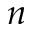<formula> <loc_0><loc_0><loc_500><loc_500>n</formula> 